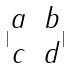Convert formula to latex. <formula><loc_0><loc_0><loc_500><loc_500>| \begin{matrix} a & b \\ c & d \end{matrix} |</formula> 